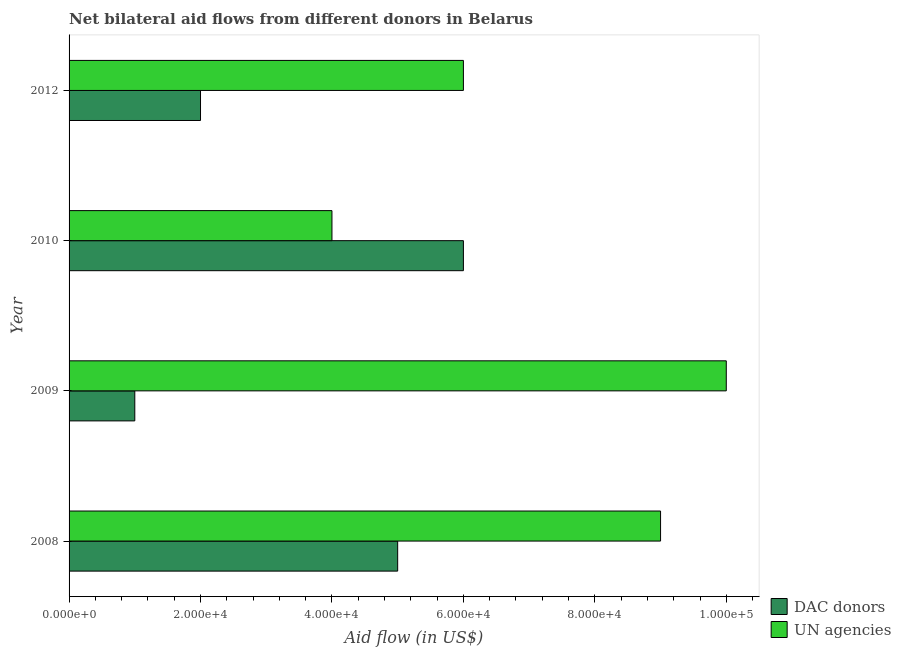Are the number of bars per tick equal to the number of legend labels?
Your answer should be very brief. Yes. What is the aid flow from un agencies in 2012?
Your response must be concise. 6.00e+04. Across all years, what is the maximum aid flow from dac donors?
Keep it short and to the point. 6.00e+04. Across all years, what is the minimum aid flow from un agencies?
Your answer should be very brief. 4.00e+04. In which year was the aid flow from un agencies minimum?
Your answer should be compact. 2010. What is the total aid flow from dac donors in the graph?
Offer a terse response. 1.40e+05. What is the difference between the aid flow from un agencies in 2008 and that in 2012?
Give a very brief answer. 3.00e+04. What is the difference between the aid flow from un agencies in 2008 and the aid flow from dac donors in 2009?
Provide a succinct answer. 8.00e+04. What is the average aid flow from un agencies per year?
Offer a terse response. 7.25e+04. In the year 2009, what is the difference between the aid flow from un agencies and aid flow from dac donors?
Offer a very short reply. 9.00e+04. In how many years, is the aid flow from un agencies greater than 32000 US$?
Offer a terse response. 4. What is the ratio of the aid flow from un agencies in 2009 to that in 2010?
Your answer should be very brief. 2.5. Is the difference between the aid flow from dac donors in 2008 and 2012 greater than the difference between the aid flow from un agencies in 2008 and 2012?
Provide a short and direct response. No. What is the difference between the highest and the lowest aid flow from dac donors?
Offer a very short reply. 5.00e+04. In how many years, is the aid flow from dac donors greater than the average aid flow from dac donors taken over all years?
Make the answer very short. 2. Is the sum of the aid flow from un agencies in 2010 and 2012 greater than the maximum aid flow from dac donors across all years?
Your answer should be compact. Yes. What does the 1st bar from the top in 2008 represents?
Your answer should be very brief. UN agencies. What does the 2nd bar from the bottom in 2009 represents?
Make the answer very short. UN agencies. How many bars are there?
Your answer should be compact. 8. How many years are there in the graph?
Offer a terse response. 4. Are the values on the major ticks of X-axis written in scientific E-notation?
Provide a succinct answer. Yes. Where does the legend appear in the graph?
Offer a terse response. Bottom right. How many legend labels are there?
Provide a succinct answer. 2. How are the legend labels stacked?
Provide a short and direct response. Vertical. What is the title of the graph?
Your answer should be compact. Net bilateral aid flows from different donors in Belarus. Does "Age 15+" appear as one of the legend labels in the graph?
Your response must be concise. No. What is the label or title of the X-axis?
Make the answer very short. Aid flow (in US$). What is the Aid flow (in US$) of UN agencies in 2008?
Your response must be concise. 9.00e+04. What is the Aid flow (in US$) in DAC donors in 2009?
Make the answer very short. 10000. What is the Aid flow (in US$) of UN agencies in 2009?
Your response must be concise. 1.00e+05. What is the Aid flow (in US$) of UN agencies in 2010?
Provide a succinct answer. 4.00e+04. What is the Aid flow (in US$) of DAC donors in 2012?
Your response must be concise. 2.00e+04. What is the Aid flow (in US$) in UN agencies in 2012?
Your answer should be very brief. 6.00e+04. Across all years, what is the maximum Aid flow (in US$) in DAC donors?
Give a very brief answer. 6.00e+04. Across all years, what is the maximum Aid flow (in US$) in UN agencies?
Make the answer very short. 1.00e+05. Across all years, what is the minimum Aid flow (in US$) in DAC donors?
Your answer should be very brief. 10000. Across all years, what is the minimum Aid flow (in US$) of UN agencies?
Provide a short and direct response. 4.00e+04. What is the total Aid flow (in US$) in DAC donors in the graph?
Ensure brevity in your answer.  1.40e+05. What is the difference between the Aid flow (in US$) in DAC donors in 2008 and that in 2009?
Your response must be concise. 4.00e+04. What is the difference between the Aid flow (in US$) in UN agencies in 2008 and that in 2009?
Offer a terse response. -10000. What is the difference between the Aid flow (in US$) in DAC donors in 2008 and that in 2010?
Keep it short and to the point. -10000. What is the difference between the Aid flow (in US$) in UN agencies in 2008 and that in 2010?
Offer a very short reply. 5.00e+04. What is the difference between the Aid flow (in US$) of UN agencies in 2008 and that in 2012?
Offer a terse response. 3.00e+04. What is the difference between the Aid flow (in US$) of DAC donors in 2009 and that in 2010?
Offer a very short reply. -5.00e+04. What is the difference between the Aid flow (in US$) in UN agencies in 2010 and that in 2012?
Provide a short and direct response. -2.00e+04. What is the difference between the Aid flow (in US$) of DAC donors in 2008 and the Aid flow (in US$) of UN agencies in 2009?
Give a very brief answer. -5.00e+04. What is the difference between the Aid flow (in US$) in DAC donors in 2008 and the Aid flow (in US$) in UN agencies in 2012?
Make the answer very short. -10000. What is the average Aid flow (in US$) in DAC donors per year?
Provide a succinct answer. 3.50e+04. What is the average Aid flow (in US$) of UN agencies per year?
Provide a succinct answer. 7.25e+04. In the year 2009, what is the difference between the Aid flow (in US$) in DAC donors and Aid flow (in US$) in UN agencies?
Offer a terse response. -9.00e+04. In the year 2010, what is the difference between the Aid flow (in US$) of DAC donors and Aid flow (in US$) of UN agencies?
Your response must be concise. 2.00e+04. What is the ratio of the Aid flow (in US$) in DAC donors in 2008 to that in 2009?
Offer a very short reply. 5. What is the ratio of the Aid flow (in US$) in UN agencies in 2008 to that in 2009?
Provide a succinct answer. 0.9. What is the ratio of the Aid flow (in US$) of UN agencies in 2008 to that in 2010?
Provide a succinct answer. 2.25. What is the ratio of the Aid flow (in US$) of DAC donors in 2008 to that in 2012?
Provide a short and direct response. 2.5. What is the ratio of the Aid flow (in US$) of UN agencies in 2008 to that in 2012?
Keep it short and to the point. 1.5. What is the ratio of the Aid flow (in US$) of DAC donors in 2009 to that in 2012?
Offer a terse response. 0.5. What is the ratio of the Aid flow (in US$) of DAC donors in 2010 to that in 2012?
Make the answer very short. 3. What is the difference between the highest and the second highest Aid flow (in US$) of UN agencies?
Give a very brief answer. 10000. What is the difference between the highest and the lowest Aid flow (in US$) of DAC donors?
Offer a very short reply. 5.00e+04. What is the difference between the highest and the lowest Aid flow (in US$) of UN agencies?
Offer a very short reply. 6.00e+04. 